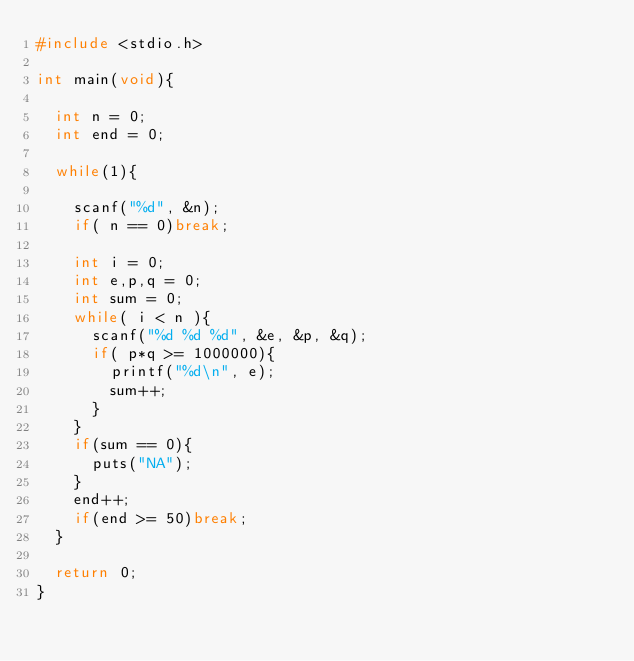<code> <loc_0><loc_0><loc_500><loc_500><_C_>#include <stdio.h>

int main(void){
	
	int n = 0;
	int end = 0;
	
	while(1){
		
		scanf("%d", &n);
		if( n == 0)break;
		
		int i = 0;
		int e,p,q = 0;
		int sum = 0;
		while( i < n ){
			scanf("%d %d %d", &e, &p, &q);
			if( p*q >= 1000000){
				printf("%d\n", e);
				sum++;
			}
		}
		if(sum == 0){
			puts("NA");
		}
		end++;
		if(end >= 50)break;
	}
	
	return 0;
}</code> 